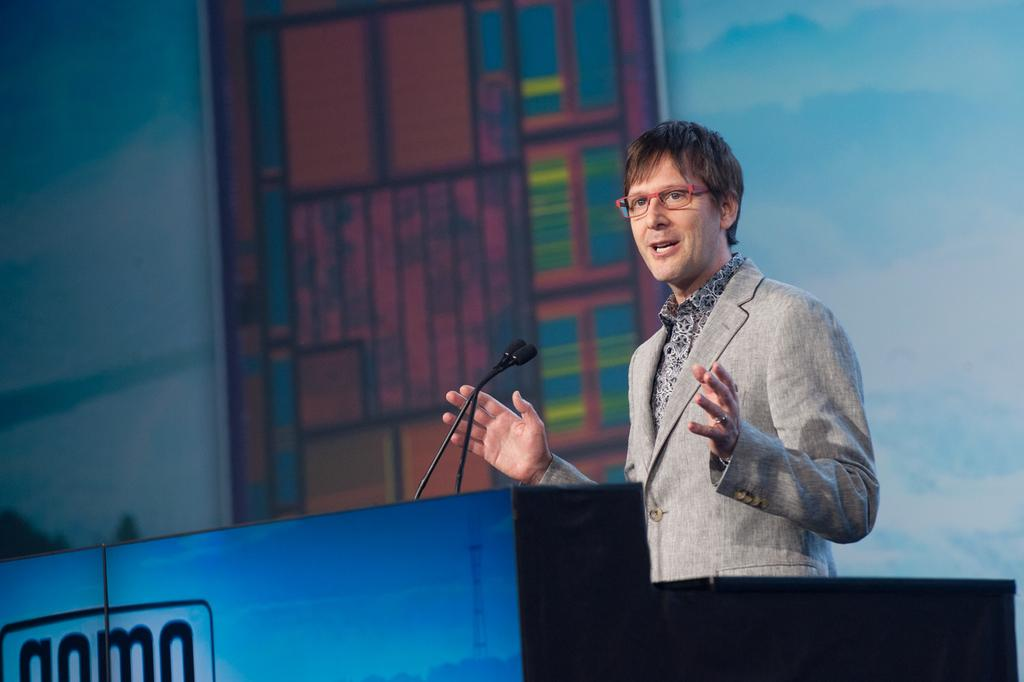Who is the main subject in the image? There is a man in the image. What is the man doing in the image? The man is standing at a podium and speaking. What objects are present to aid the man in his speech? Microphones are present in the image. What information can be seen on the podium? There is text on the podium. What can be seen in the background of the image? There appears to be a screen in the background. What type of plate is being used to slow down the man's speech in the image? There is no plate present in the image, and the man's speech is not being slowed down by any object. 